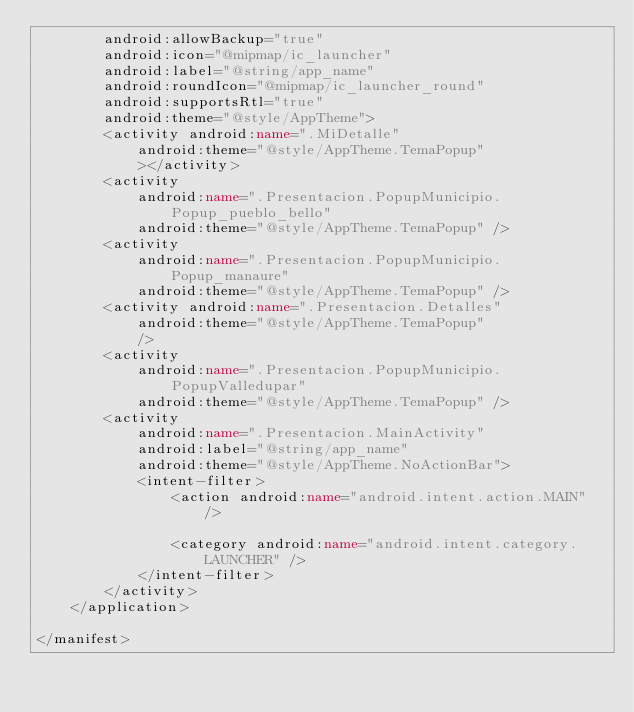Convert code to text. <code><loc_0><loc_0><loc_500><loc_500><_XML_>        android:allowBackup="true"
        android:icon="@mipmap/ic_launcher"
        android:label="@string/app_name"
        android:roundIcon="@mipmap/ic_launcher_round"
        android:supportsRtl="true"
        android:theme="@style/AppTheme">
        <activity android:name=".MiDetalle"
            android:theme="@style/AppTheme.TemaPopup"
            ></activity>
        <activity
            android:name=".Presentacion.PopupMunicipio.Popup_pueblo_bello"
            android:theme="@style/AppTheme.TemaPopup" />
        <activity
            android:name=".Presentacion.PopupMunicipio.Popup_manaure"
            android:theme="@style/AppTheme.TemaPopup" />
        <activity android:name=".Presentacion.Detalles"
            android:theme="@style/AppTheme.TemaPopup"
            />
        <activity
            android:name=".Presentacion.PopupMunicipio.PopupValledupar"
            android:theme="@style/AppTheme.TemaPopup" />
        <activity
            android:name=".Presentacion.MainActivity"
            android:label="@string/app_name"
            android:theme="@style/AppTheme.NoActionBar">
            <intent-filter>
                <action android:name="android.intent.action.MAIN" />

                <category android:name="android.intent.category.LAUNCHER" />
            </intent-filter>
        </activity>
    </application>

</manifest></code> 